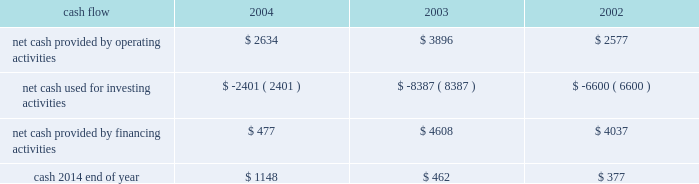On october 21 , 2004 , the hartford declared a dividend on its common stock of $ 0.29 per share payable on january 3 , 2005 to shareholders of record as of december 1 , 2004 .
The hartford declared $ 331 and paid $ 325 in dividends to shareholders in 2004 , declared $ 300 and paid $ 291 in dividends to shareholders in 2003 , declared $ 262 and paid $ 257 in 2002 .
Aoci - aoci increased by $ 179 as of december 31 , 2004 compared with december 31 , 2003 .
The increase in aoci is primarily the result of life 2019s adoption of sop 03-1 , which resulted in a $ 292 cumulative effect for unrealized gains on securities in the first quarter of 2004 related to the reclassification of investments from separate account assets to general account assets , partially offset by net unrealized losses on cash-flow hedging instruments .
The funded status of the company 2019s pension and postretirement plans is dependent upon many factors , including returns on invested assets and the level of market interest rates .
Declines in the value of securities traded in equity markets coupled with declines in long- term interest rates have had a negative impact on the funded status of the plans .
As a result , the company recorded a minimum pension liability as of december 31 , 2004 , and 2003 , which resulted in an after-tax reduction of stockholders 2019 equity of $ 480 and $ 375 respectively .
This minimum pension liability did not affect the company 2019s results of operations .
For additional information on stockholders 2019 equity and aoci see notes 15 and 16 , respectively , of notes to consolidated financial statements .
Cash flow 2004 2003 2002 .
2004 compared to 2003 2014 cash from operating activities primarily reflects premium cash flows in excess of claim payments .
The decrease in cash provided by operating activities was due primarily to the $ 1.15 billion settlement of the macarthur litigation in 2004 .
Cash provided by financing activities decreased primarily due to lower proceeds from investment and universal life-type contracts as a result of the adoption of sop 03-1 , decreased capital raising activities , repayment of commercial paper and early retirement of junior subordinated debentures in 2004 .
The decrease in cash from financing activities and operating cash flows invested long-term accounted for the majority of the change in cash used for investing activities .
2003 compared to 2002 2014 the increase in cash provided by operating activities was primarily the result of strong premium cash flows .
Financing activities increased primarily due to capital raising activities related to the 2003 asbestos reserve addition and decreased due to repayments on long-term debt and lower proceeds from investment and universal life-type contracts .
The increase in cash from financing activities accounted for the majority of the change in cash used for investing activities .
Operating cash flows in each of the last three years have been adequate to meet liquidity requirements .
Equity markets for a discussion of the potential impact of the equity markets on capital and liquidity , see the capital markets risk management section under 201cmarket risk 201d .
Ratings ratings are an important factor in establishing the competitive position in the insurance and financial services marketplace .
There can be no assurance that the company's ratings will continue for any given period of time or that they will not be changed .
In the event the company's ratings are downgraded , the level of revenues or the persistency of the company's business may be adversely impacted .
On august 4 , 2004 , moody 2019s affirmed the company 2019s and hartford life , inc . 2019s a3 senior debt ratings as well as the aa3 insurance financial strength ratings of both its property-casualty and life insurance operating subsidiaries .
In addition , moody 2019s changed the outlook for all of these ratings from negative to stable .
Since the announcement of the suit filed by the new york attorney general 2019s office against marsh & mclennan companies , inc. , and marsh , inc .
On october 14 , 2004 , the major independent ratings agencies have indicated that they continue to monitor developments relating to the suit .
On october 22 , 2004 , standard & poor 2019s revised its outlook on the u.s .
Property/casualty commercial lines sector to negative from stable .
On november 23 , 2004 , standard & poor 2019s revised its outlook on the financial strength and credit ratings of the property-casualty insurance subsidiaries to negative from stable .
The outlook on the life insurance subsidiaries and corporate debt was unaffected. .
What is the chance in net cash flow generated from operating activities from 2003 to 2004? 
Computations: (2634 - 3896)
Answer: -1262.0. 